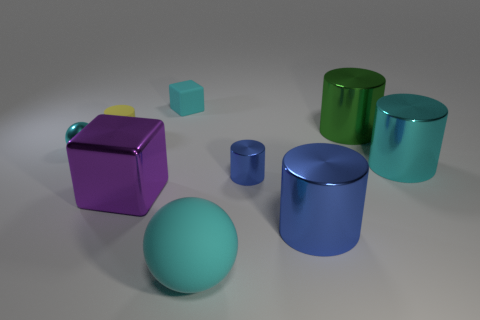What shape is the shiny thing on the left side of the tiny yellow matte cylinder?
Provide a succinct answer. Sphere. Is the small cylinder behind the small cyan sphere made of the same material as the cylinder that is to the right of the green cylinder?
Make the answer very short. No. What number of yellow rubber objects are the same shape as the big purple object?
Provide a succinct answer. 0. What material is the big ball that is the same color as the matte block?
Keep it short and to the point. Rubber. What number of things are either big green metallic spheres or things that are on the left side of the yellow matte thing?
Give a very brief answer. 1. What is the material of the purple object?
Keep it short and to the point. Metal. There is a tiny blue object that is the same shape as the green thing; what material is it?
Your answer should be very brief. Metal. What color is the tiny cylinder to the right of the ball that is to the right of the small shiny sphere?
Your response must be concise. Blue. What number of shiny objects are either large yellow blocks or small blue things?
Provide a short and direct response. 1. Are the yellow cylinder and the big cube made of the same material?
Provide a succinct answer. No. 